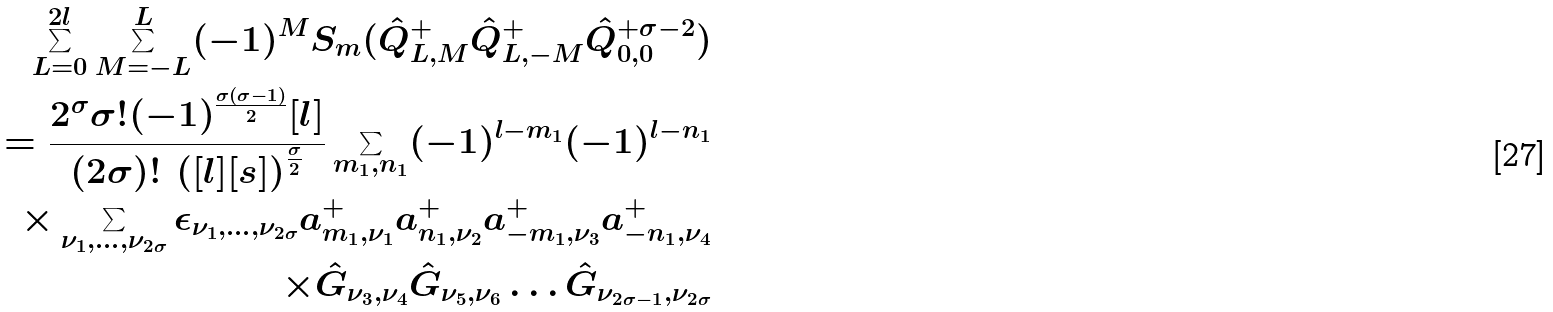Convert formula to latex. <formula><loc_0><loc_0><loc_500><loc_500>\sum _ { L = 0 } ^ { 2 l } \sum _ { M = - L } ^ { L } ( - 1 ) ^ { M } S _ { m } ( \hat { Q } ^ { + } _ { L , M } \hat { Q } ^ { + } _ { L , - M } \hat { Q } ^ { + \sigma - 2 } _ { 0 , 0 } ) \\ = \frac { 2 ^ { \sigma } \sigma ! ( - 1 ) ^ { \frac { \sigma ( \sigma - 1 ) } { 2 } } [ l ] } { ( 2 \sigma ) ! \, \left ( [ l ] [ s ] \right ) ^ { \frac { \sigma } { 2 } } } \sum _ { m _ { 1 } , n _ { 1 } } ( - 1 ) ^ { l - m _ { 1 } } ( - 1 ) ^ { l - n _ { 1 } } \\ \times \sum _ { \nu _ { 1 } , \dots , \nu _ { 2 \sigma } } \epsilon _ { \nu _ { 1 } , \dots , \nu _ { 2 \sigma } } a _ { m _ { 1 } , \nu _ { 1 } } ^ { + } a _ { n _ { 1 } , \nu _ { 2 } } ^ { + } a _ { - m _ { 1 } , \nu _ { 3 } } ^ { + } a _ { - n _ { 1 } , \nu _ { 4 } } ^ { + } \\ \times \hat { G } _ { \nu _ { 3 } , \nu _ { 4 } } \hat { G } _ { \nu _ { 5 } , \nu _ { 6 } } \dots \hat { G } _ { \nu _ { 2 \sigma - 1 } , \nu _ { 2 \sigma } }</formula> 